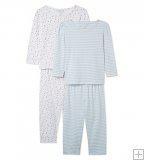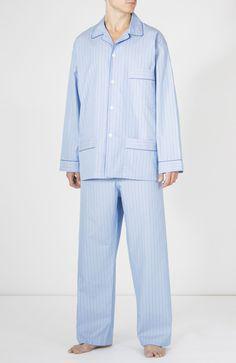The first image is the image on the left, the second image is the image on the right. Analyze the images presented: Is the assertion "One pair of men's blue pajamas with long sleeves is worn by a model, while a second pair is displayed on a hanger." valid? Answer yes or no. No. The first image is the image on the left, the second image is the image on the right. Evaluate the accuracy of this statement regarding the images: "An image shows two overlapping sleep outfits that are not worn by models or mannequins.". Is it true? Answer yes or no. Yes. 